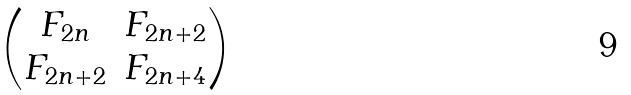Convert formula to latex. <formula><loc_0><loc_0><loc_500><loc_500>\begin{pmatrix} F _ { 2 n } & F _ { 2 n + 2 } \\ F _ { 2 n + 2 } & F _ { 2 n + 4 } \end{pmatrix}</formula> 